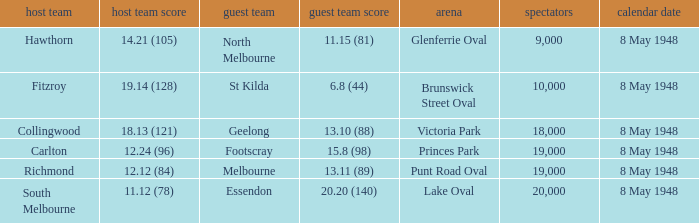Which home team has a score of 11.12 (78)? South Melbourne. 